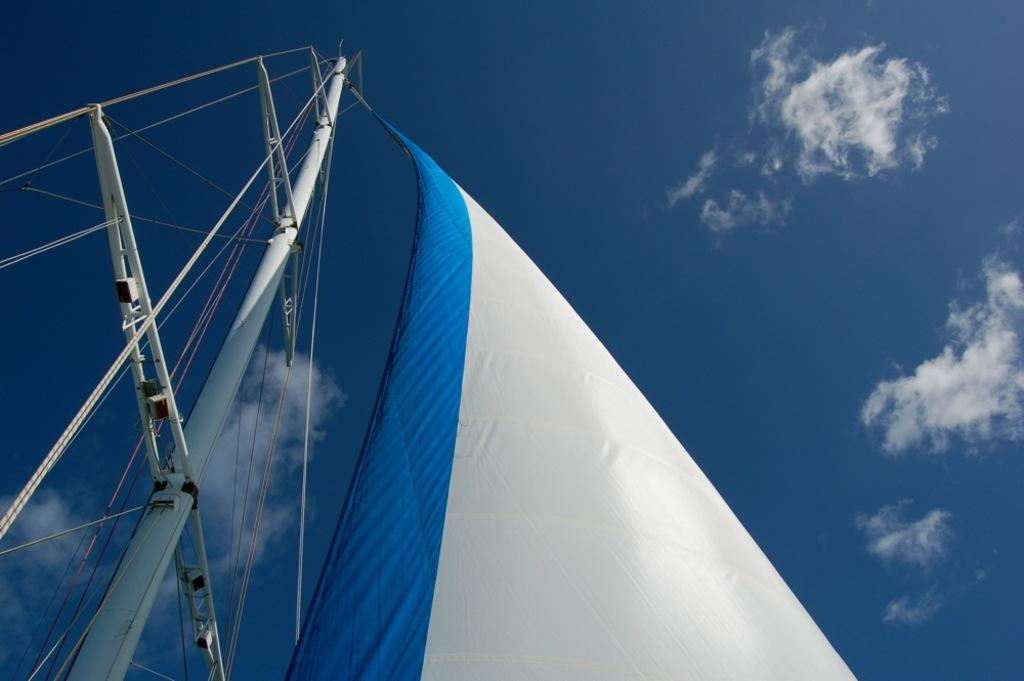What is the main object in the image? There is a ship's sail in the image. What feature can be seen on the sail? The sail has a rod. What colors are used for the sail? The sail is in blue and white colors. What is visible at the top of the image? The sky is visible at the top of the image, and it is clear. Can you tell me how many leaves are on the sidewalk in the image? There are no leaves or sidewalks present in the image; it features a ship's sail with a rod and a clear sky. What type of creature is shown turning the sail in the image? There is no creature shown turning the sail in the image; only the sail and its rod are present. 